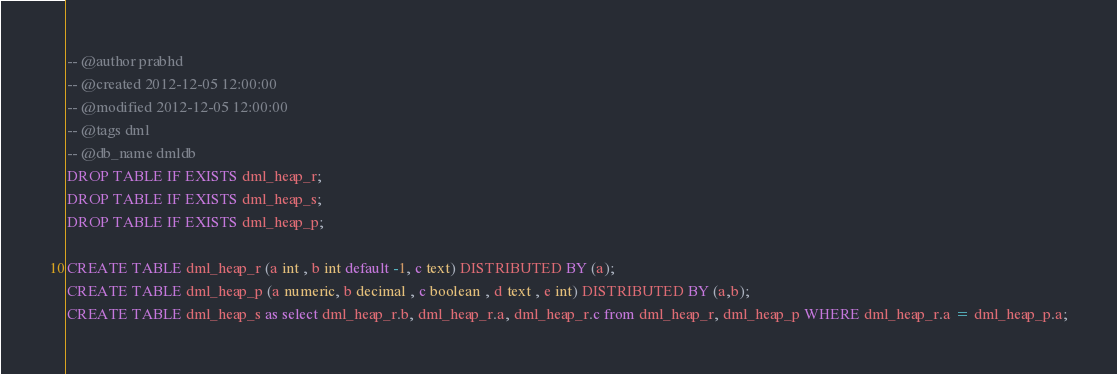<code> <loc_0><loc_0><loc_500><loc_500><_SQL_>-- @author prabhd  
-- @created 2012-12-05 12:00:00  
-- @modified 2012-12-05 12:00:00 
-- @tags dml 
-- @db_name dmldb
DROP TABLE IF EXISTS dml_heap_r;
DROP TABLE IF EXISTS dml_heap_s;
DROP TABLE IF EXISTS dml_heap_p;

CREATE TABLE dml_heap_r (a int , b int default -1, c text) DISTRIBUTED BY (a);
CREATE TABLE dml_heap_p (a numeric, b decimal , c boolean , d text , e int) DISTRIBUTED BY (a,b);
CREATE TABLE dml_heap_s as select dml_heap_r.b, dml_heap_r.a, dml_heap_r.c from dml_heap_r, dml_heap_p WHERE dml_heap_r.a = dml_heap_p.a;</code> 